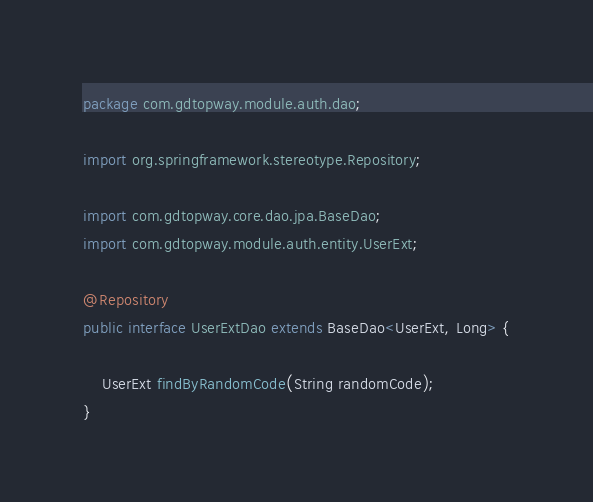<code> <loc_0><loc_0><loc_500><loc_500><_Java_>package com.gdtopway.module.auth.dao;

import org.springframework.stereotype.Repository;

import com.gdtopway.core.dao.jpa.BaseDao;
import com.gdtopway.module.auth.entity.UserExt;

@Repository
public interface UserExtDao extends BaseDao<UserExt, Long> {

    UserExt findByRandomCode(String randomCode);
}</code> 